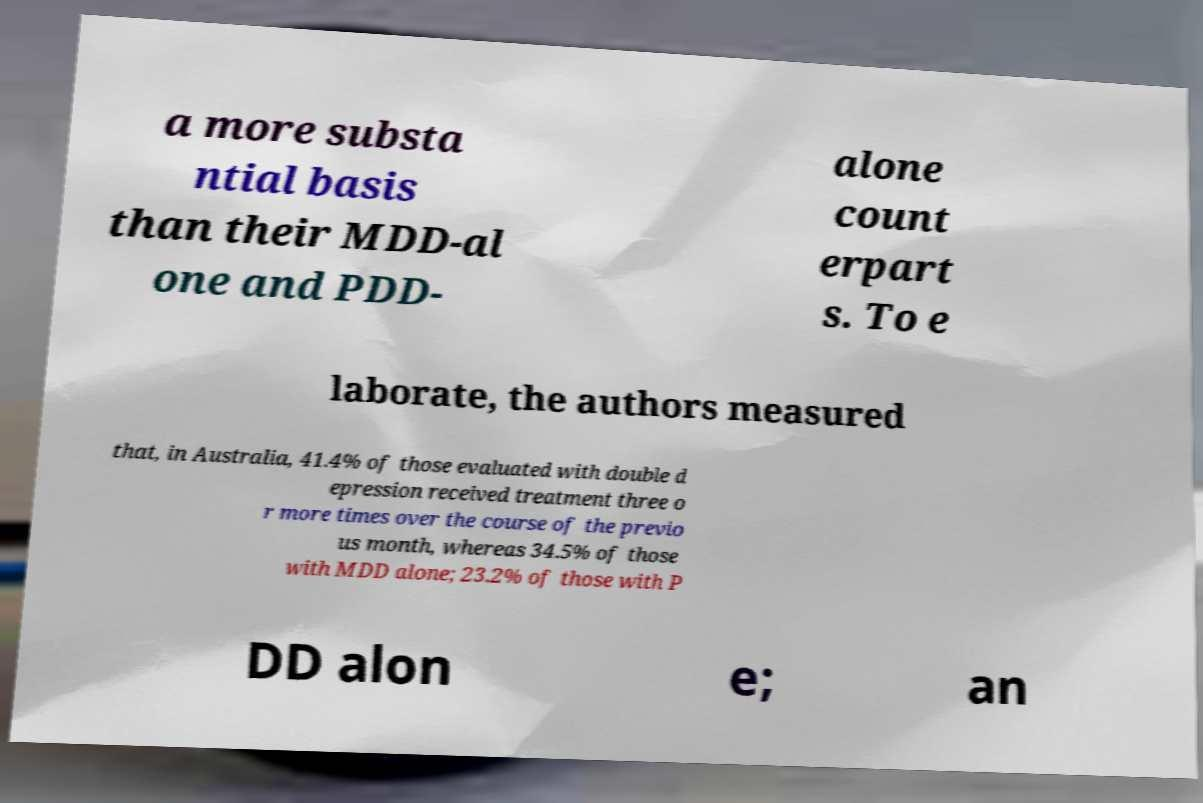Can you accurately transcribe the text from the provided image for me? a more substa ntial basis than their MDD-al one and PDD- alone count erpart s. To e laborate, the authors measured that, in Australia, 41.4% of those evaluated with double d epression received treatment three o r more times over the course of the previo us month, whereas 34.5% of those with MDD alone; 23.2% of those with P DD alon e; an 